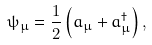<formula> <loc_0><loc_0><loc_500><loc_500>\psi _ { \mu } = \frac { 1 } { 2 } \left ( a _ { \mu } + a _ { \mu } ^ { \dag } \right ) ,</formula> 